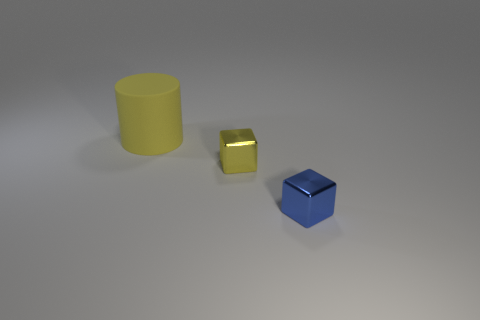Add 3 tiny yellow shiny things. How many objects exist? 6 Subtract all cylinders. How many objects are left? 2 Add 2 brown shiny things. How many brown shiny things exist? 2 Subtract 0 purple cubes. How many objects are left? 3 Subtract all large yellow rubber cylinders. Subtract all tiny metallic blocks. How many objects are left? 0 Add 1 big yellow matte things. How many big yellow matte things are left? 2 